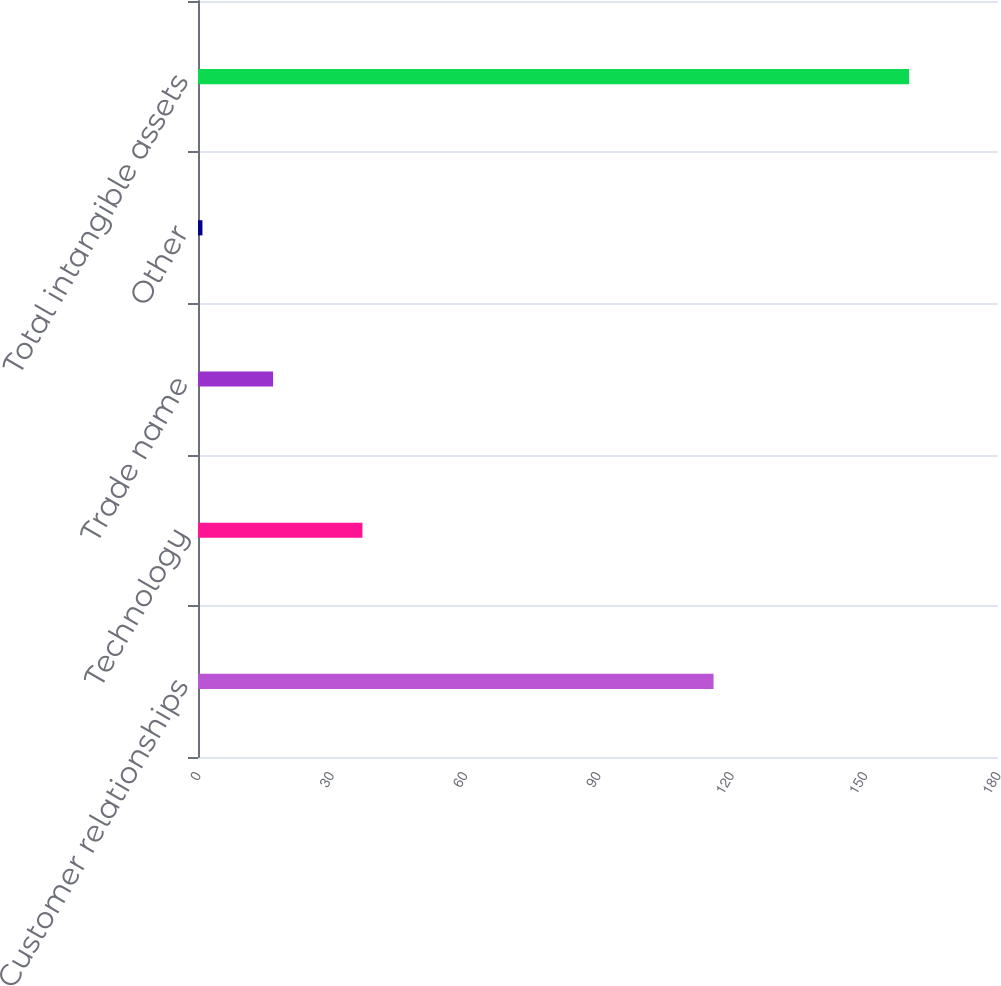Convert chart. <chart><loc_0><loc_0><loc_500><loc_500><bar_chart><fcel>Customer relationships<fcel>Technology<fcel>Trade name<fcel>Other<fcel>Total intangible assets<nl><fcel>116<fcel>37<fcel>16.9<fcel>1<fcel>160<nl></chart> 